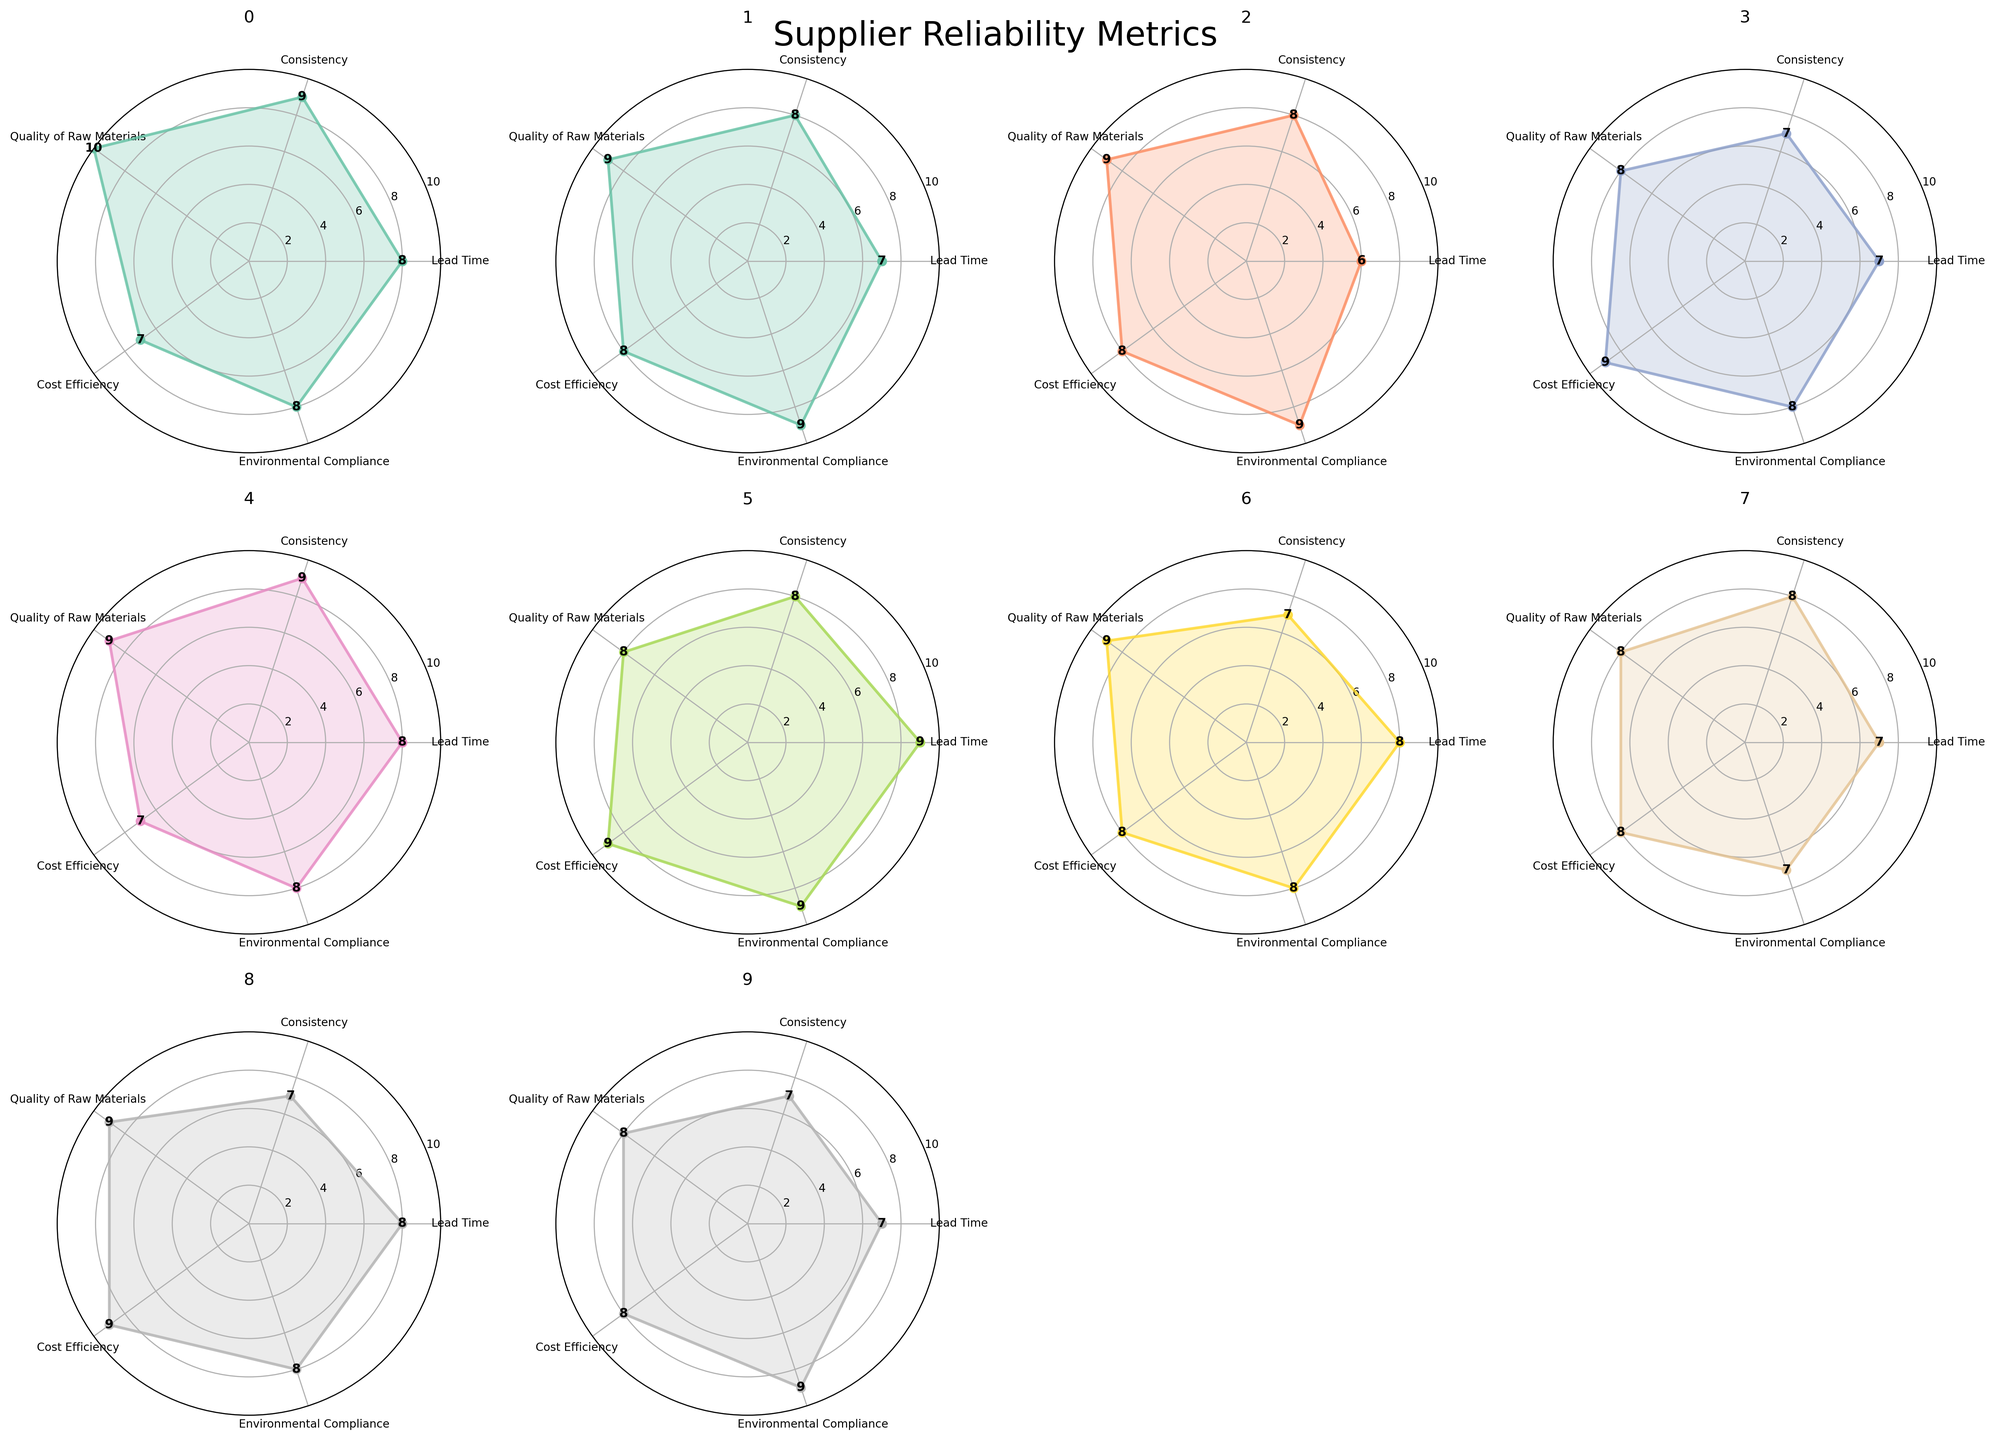What is the title of the figure? The title is located at the top of the figure and reads "Supplier Reliability Metrics."
Answer: Supplier Reliability Metrics Which supplier has the highest lead time? From the radar charts, check the Lead Time metric for each supplier and spot the highest value. Nippon Paint has a lead-time value of 9.
Answer: Nippon Paint Which metrics are consistently high for Sherwin-Williams? Look at Sherwin-Williams' radar chart and identify the metrics with values >= 8. Lead Time, Consistency, Quality of Raw Materials, and Environmental Compliance all have values >= 8.
Answer: Lead Time, Consistency, Quality of Raw Materials, Environmental Compliance What is the average cost efficiency rating across all suppliers? Sum the Cost Efficiency values for all suppliers and divide by the number of suppliers. (7+8+8+9+7+9+8+8+9+8) / 10 = 81 / 10 = 8.1.
Answer: 8.1 Compare the environmental compliance of BASF and Dow Chemical. Which is better? For BASF, Environmental Compliance is 8. For Dow Chemical, Environmental Compliance is 9. Dow Chemical’s metric is higher.
Answer: Dow Chemical Which two suppliers have the closest metrics in terms of quality of raw materials? Check the Quality of Raw Materials values and find the smallest difference between two suppliers. BASF and Dow Chemical both have values of 9 and 10, which is a difference of 1. Akzo Nobel and Dow Chemical also have these values.
Answer: BASF and Dow Chemical What is the total consistency rating for all suppliers? Sum the Consistency values for all suppliers. 9 + 8 + 8 + 7 + 9 + 8 + 7 + 8 + 7 + 7 = 78.
Answer: 78 Which supplier has the lowest consistency rating? Find the supplier with the lowest value in the Consistency metric. PPG Industries, Asian Paints, and RPM International all have the lowest value of 7.
Answer: PPG Industries, Asian Paints, RPM International Identify the supplier with the most balanced radar chart. A balanced radar chart would have similar values across all metrics. Sherwin-Williams has values like 8, 9, 9, 7, and 8, showing consistency across metrics.
Answer: Sherwin-Williams 